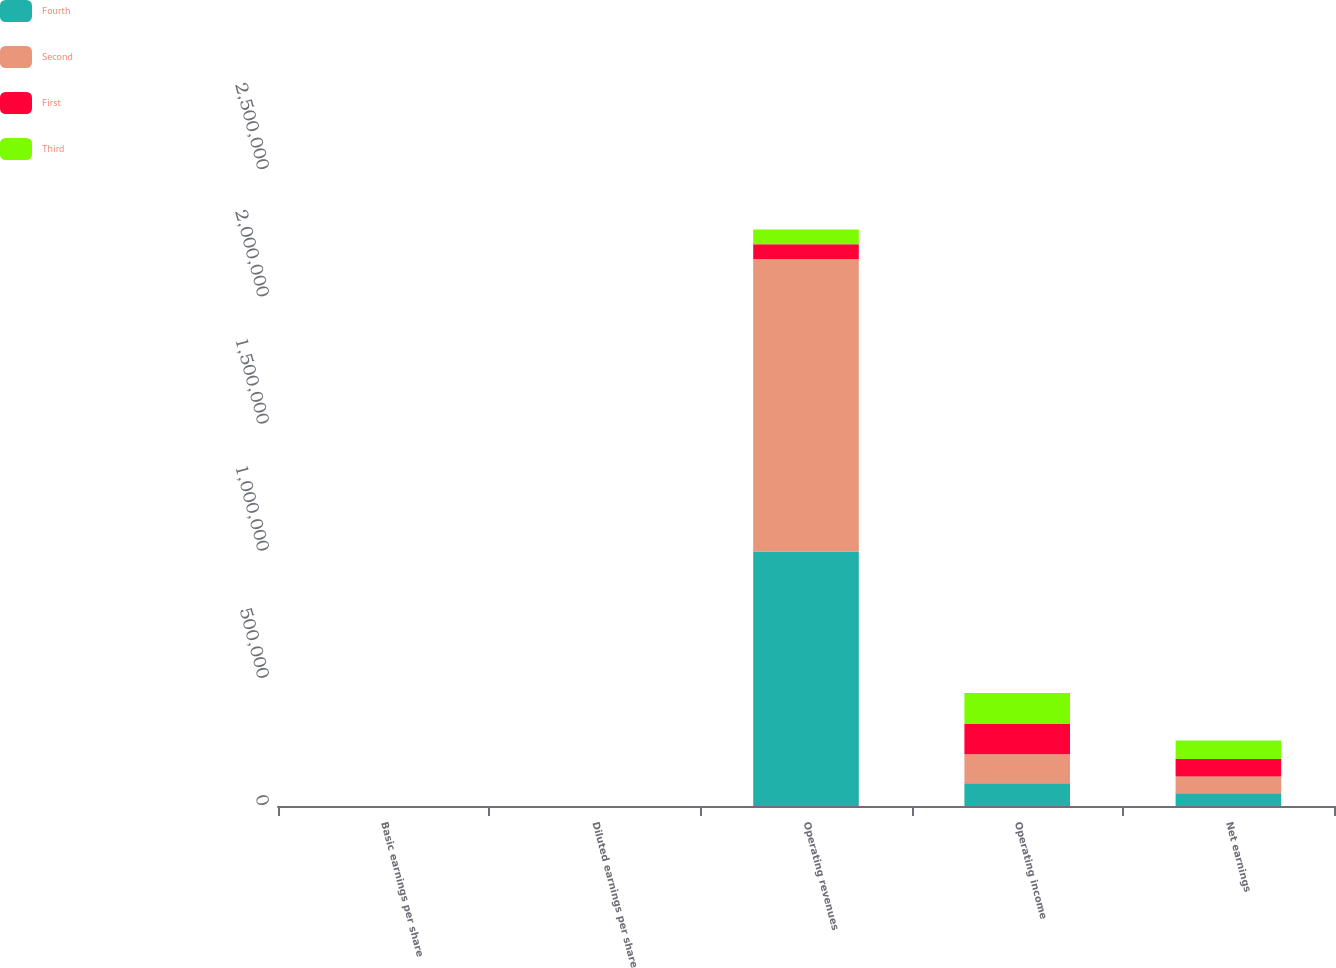Convert chart to OTSL. <chart><loc_0><loc_0><loc_500><loc_500><stacked_bar_chart><ecel><fcel>Basic earnings per share<fcel>Diluted earnings per share<fcel>Operating revenues<fcel>Operating income<fcel>Net earnings<nl><fcel>Fourth<fcel>0.58<fcel>0.57<fcel>1.00078e+06<fcel>89823<fcel>50095<nl><fcel>Second<fcel>0.69<fcel>0.67<fcel>1.14986e+06<fcel>113443<fcel>65696<nl><fcel>First<fcel>0.66<fcel>0.65<fcel>57895.5<fcel>118680<fcel>68650<nl><fcel>Third<fcel>0.71<fcel>0.7<fcel>57895.5<fcel>122287<fcel>72565<nl></chart> 